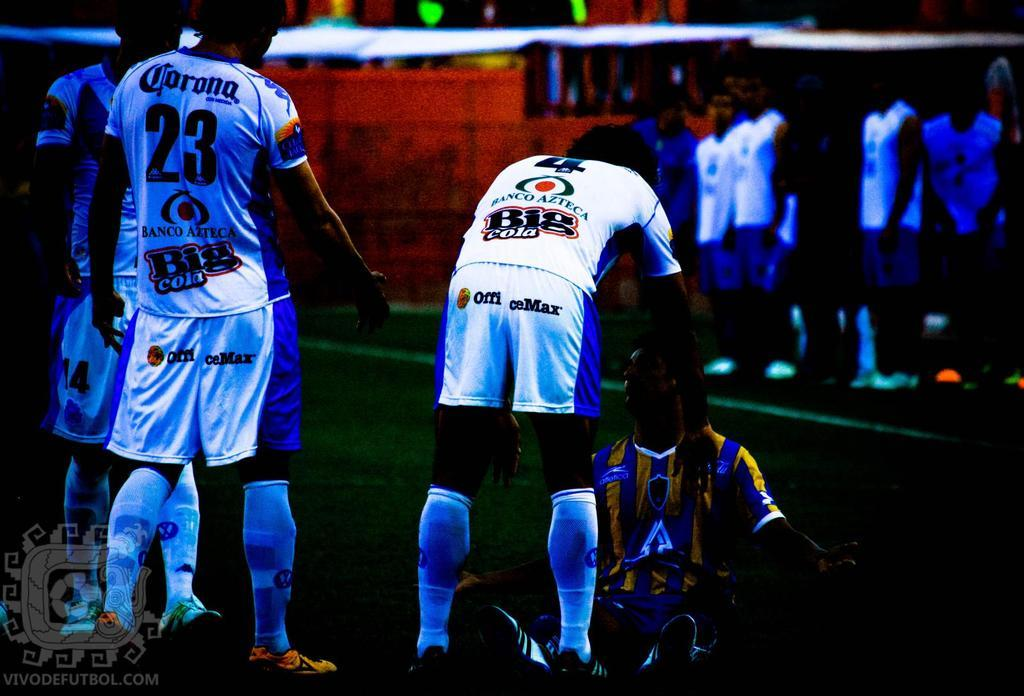Provide a one-sentence caption for the provided image. athletes wearing Corona sponsored jerseys are lined up, one interacting with an opposing player. 